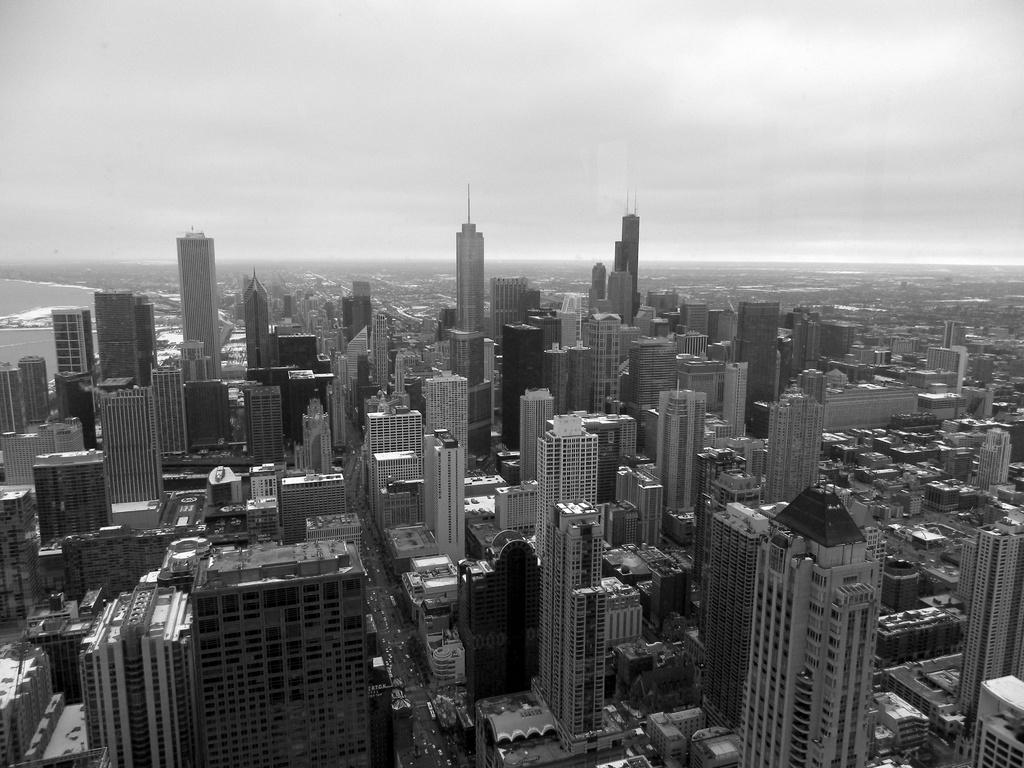What is the color scheme of the image? The image is black and white. What can be seen in the foreground of the image? There are buildings in the foreground of the image. What natural element is visible in the image? There is water visible in the image. What part of the environment is visible in the image? The sky is visible in the image. What type of line does your dad use to draw the buildings in the image? There is no information about drawing or your dad in the image, as it is a photograph or a depiction of a real scene. 